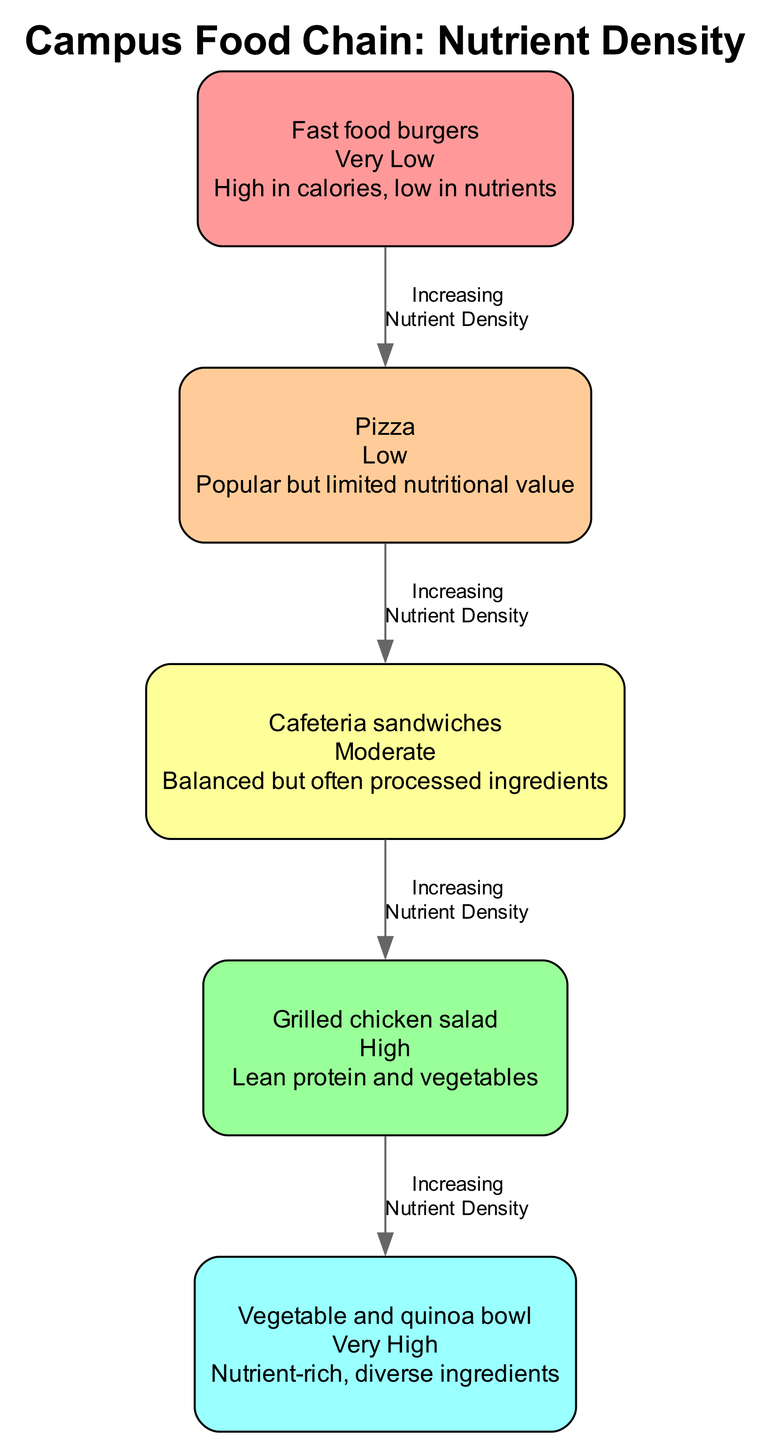What is the nutrient density of fast food burgers? According to the diagram, fast food burgers are labeled with "Very Low" nutrient density.
Answer: Very Low How many elements are in the campus food chain? The diagram shows a total of five elements, as each food item is represented as a node.
Answer: 5 What meal comes after cafeteria sandwiches in the food chain? By following the directed edges in the diagram, the next meal after cafeteria sandwiches is grilled chicken salad.
Answer: Grilled chicken salad Which meal has the highest nutrient density? The diagram indicates that the meal with the highest nutrient density is the vegetable and quinoa bowl, as it is the last node in the chain with "Very High" nutrient density.
Answer: Vegetable and quinoa bowl What is the relationship between pizza and grilled chicken salad regarding nutrient density? The diagram shows a directed edge from pizza to grilled chicken salad, indicating that grilled chicken salad has a higher nutrient density than pizza.
Answer: Grilled chicken salad has higher nutrient density Which meal has a "Moderate" nutrient density? Referring to the elements listed in the diagram, cafeteria sandwiches are labeled with "Moderate" nutrient density.
Answer: Cafeteria sandwiches How many edges are in the food chain? The food chain consists of four edges connecting the five nodes, as each node (except the last) points to the next one.
Answer: 4 What is the nutrient density of the vegetable and quinoa bowl? The diagram indicates that the vegetable and quinoa bowl has a "Very High" nutrient density.
Answer: Very High What type of relationship is indicated between the meals in the food chain? The edges in the diagram indicate an "Increasing Nutrient Density" relationship between the meals, as each subsequent meal has a higher nutrient density than the previous one.
Answer: Increasing Nutrient Density 